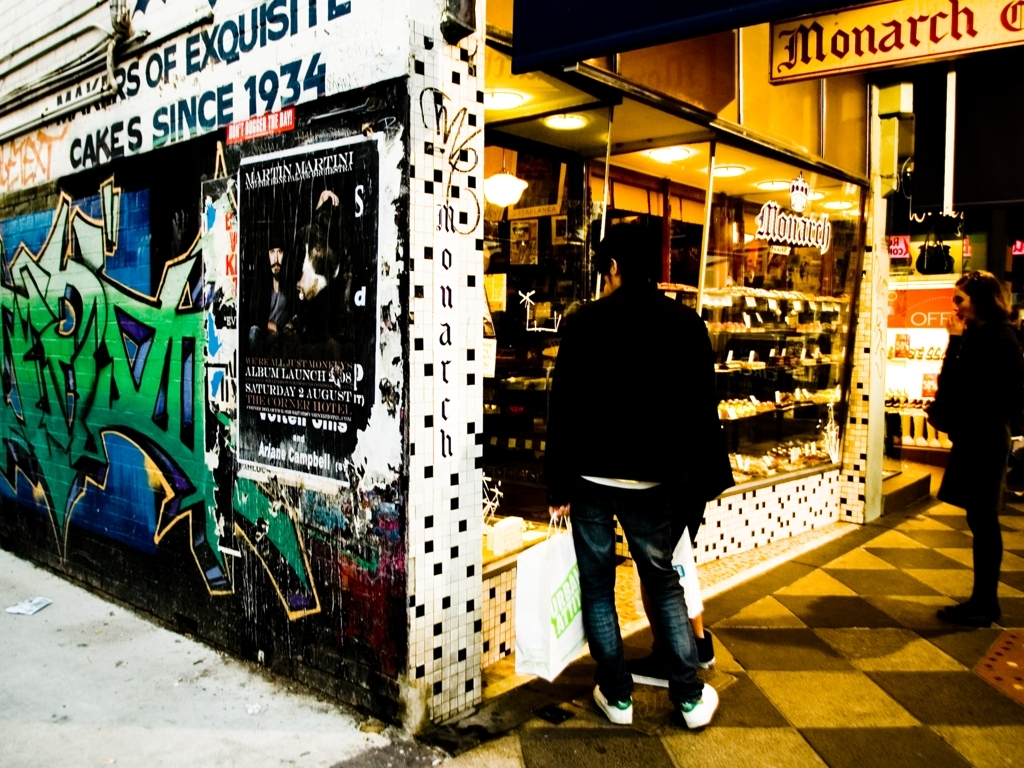What can you deduce about the location or setting from the details in this image? Given the presence of graffiti, posters, and the cake shop boasting a history dating back to 1934, we can infer this is an urban setting with a fusion of old and new cultural elements. The format of the shop sign suggests a Western location, possibly in a city with a notable art scene and a respect for historic businesses. 